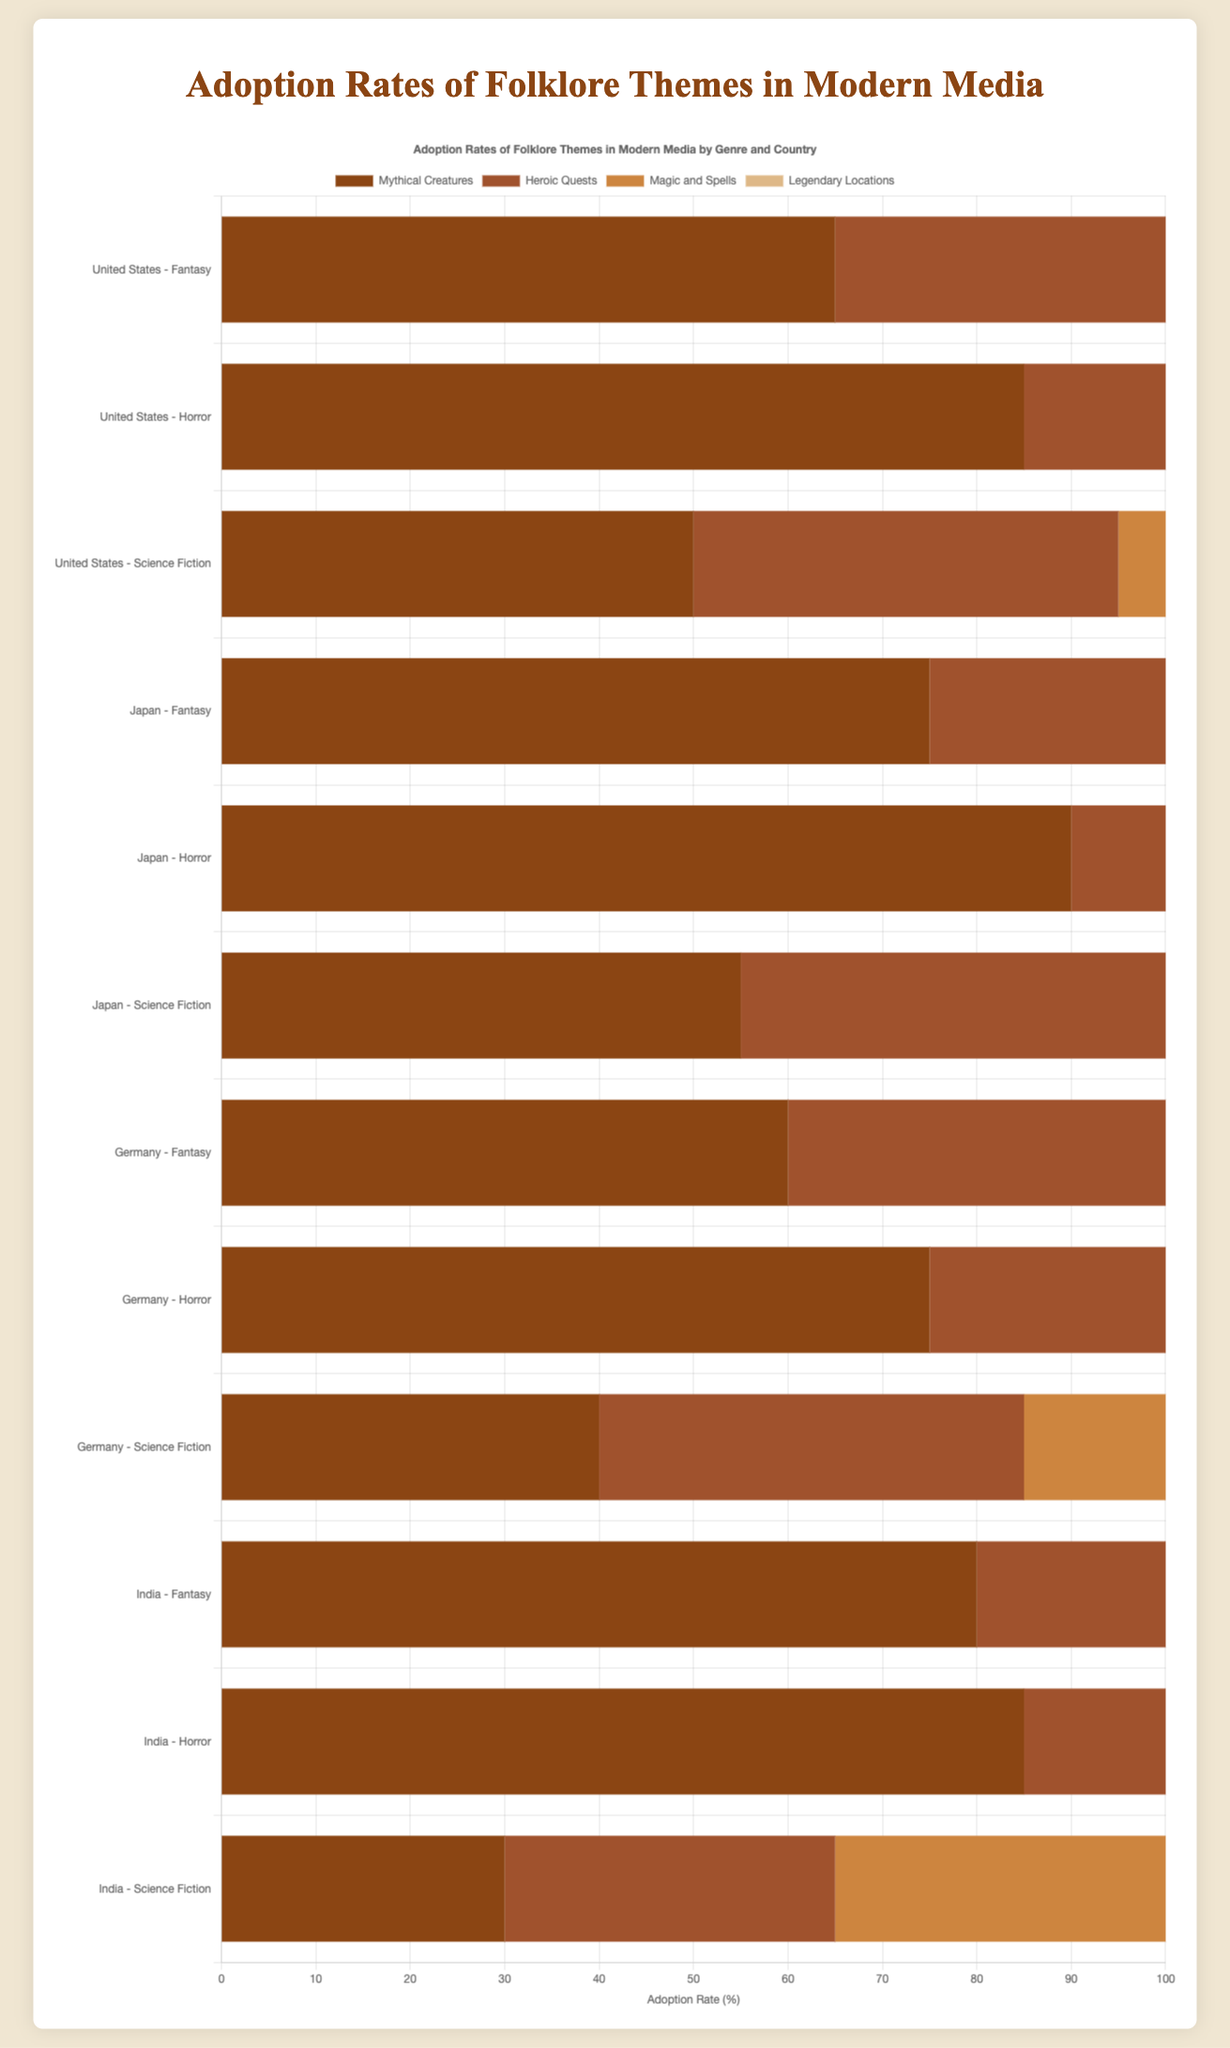Which country and genre combination has the highest adoption rate for 'Ghosts and Spirits'? First, identify the adoption rates for 'Ghosts and Spirits' across all country and genre combinations. From the figure, Japan's Horror genre has the highest rate at 90%.
Answer: Japan - Horror Which folklore theme has the highest overall adoption rate in India's Fantasy genre? Review the adoption rates for all folklore themes in India's Fantasy genre. The highest rate is for 'Heroic Quests' at 85%.
Answer: Heroic Quests Compare the adoption rates of 'Urban Legends' in Horror genres of Germany and Japan. Which country has a higher rate? Look at the adoption rates for 'Urban Legends' in Horror genres of both countries. Germany has 70% and Japan has 60%. Germany has the higher rate.
Answer: Germany What is the average adoption rate of 'Magic and Spells' across all Fantasy genres? Combine the adoption rates of 'Magic and Spells' in the Fantasy genres of all countries: (80 + 70 + 65 + 75). The sum is 290, and there are 4 data points, so the average is 290/4 = 72.5.
Answer: 72.5 In which country and genre is the adoption rate of 'Witchcraft' the lowest? Identify the adoption rates of 'Witchcraft' across all country and genre combinations. The lowest rate is in Japan's Horror genre at 45%.
Answer: Japan - Horror What is the difference in adoption rates of 'Mythical Creatures' between India's Fantasy genre and Germany's Fantasy genre? Find the adoption rates of 'Mythical Creatures' in India's Fantasy genre (80%) and Germany's Fantasy genre (60%). The difference is 80 - 60 = 20.
Answer: 20 Summarize the combined adoption rate of 'Apocalypse' for Science Fiction genres across all countries. Add the adoption rates of 'Apocalypse' in the Science Fiction genre for all countries: (55 + 70 + 60 + 55). The total is 240.
Answer: 240 Which folklore theme and country show a significant disparity in adoption rates between Horror and Science Fiction genres? Compare the adoption rates for each theme in Horror and Science Fiction genres across all countries. 'Aliens and UFOs' in India shows a discrepancy with 85% in Horror and 30% in Science Fiction, a difference of 55%.
Answer: Aliens and UFOs, India In the United States, which folklore theme has a more considerable variance between the Fantasy and Horror genres? Compare the adoption rates of each theme between Fantasy and Horror: 'Mythical Creatures' (65% - 85% = -20), 'Heroic Quests' (75% - 70% = 5), 'Magic and Spells' (80% - 70% = 10), 'Legendary Locations' (60% - 55% = 5). The largest variance is -20 for 'Mythical Creatures'.
Answer: Mythical Creatures Which folklore theme is most consistently adopted across all genres and countries? Assess the variability in adoption rates for each theme across all genres and countries. 'Apocalypse' shows more consistent rates: (55, 70, 60, 55) - within a narrower range compared to other themes.
Answer: Apocalypse 